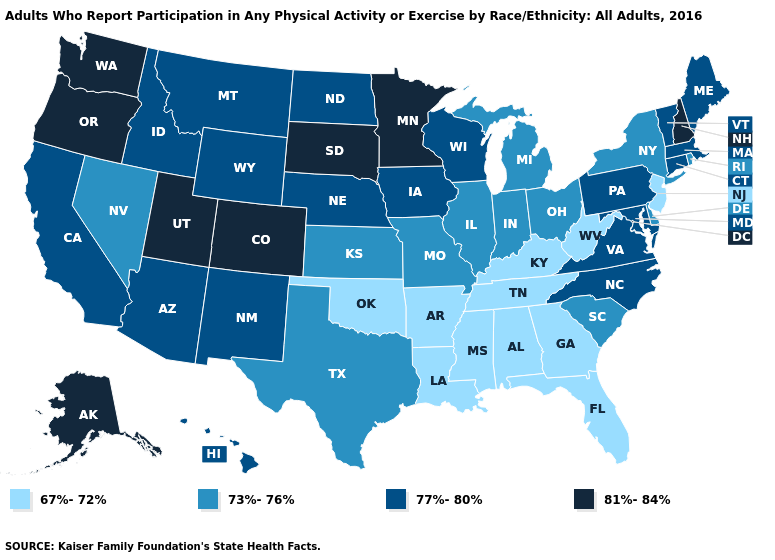What is the lowest value in states that border Arizona?
Short answer required. 73%-76%. Does Arizona have the lowest value in the West?
Answer briefly. No. Does Ohio have the lowest value in the USA?
Keep it brief. No. Name the states that have a value in the range 73%-76%?
Answer briefly. Delaware, Illinois, Indiana, Kansas, Michigan, Missouri, Nevada, New York, Ohio, Rhode Island, South Carolina, Texas. Among the states that border Georgia , does Alabama have the highest value?
Write a very short answer. No. What is the lowest value in the West?
Give a very brief answer. 73%-76%. Does the first symbol in the legend represent the smallest category?
Write a very short answer. Yes. Among the states that border Georgia , which have the highest value?
Short answer required. North Carolina. Does the first symbol in the legend represent the smallest category?
Give a very brief answer. Yes. Does the map have missing data?
Concise answer only. No. Which states have the lowest value in the USA?
Keep it brief. Alabama, Arkansas, Florida, Georgia, Kentucky, Louisiana, Mississippi, New Jersey, Oklahoma, Tennessee, West Virginia. Name the states that have a value in the range 77%-80%?
Short answer required. Arizona, California, Connecticut, Hawaii, Idaho, Iowa, Maine, Maryland, Massachusetts, Montana, Nebraska, New Mexico, North Carolina, North Dakota, Pennsylvania, Vermont, Virginia, Wisconsin, Wyoming. What is the lowest value in the West?
Quick response, please. 73%-76%. 